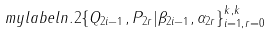Convert formula to latex. <formula><loc_0><loc_0><loc_500><loc_500>\ m y l a b e l { n . 2 } \{ Q _ { 2 i - 1 } , P _ { 2 r } | \beta _ { 2 i - 1 } , \alpha _ { 2 r } \} _ { i = 1 , r = 0 } ^ { k , k }</formula> 